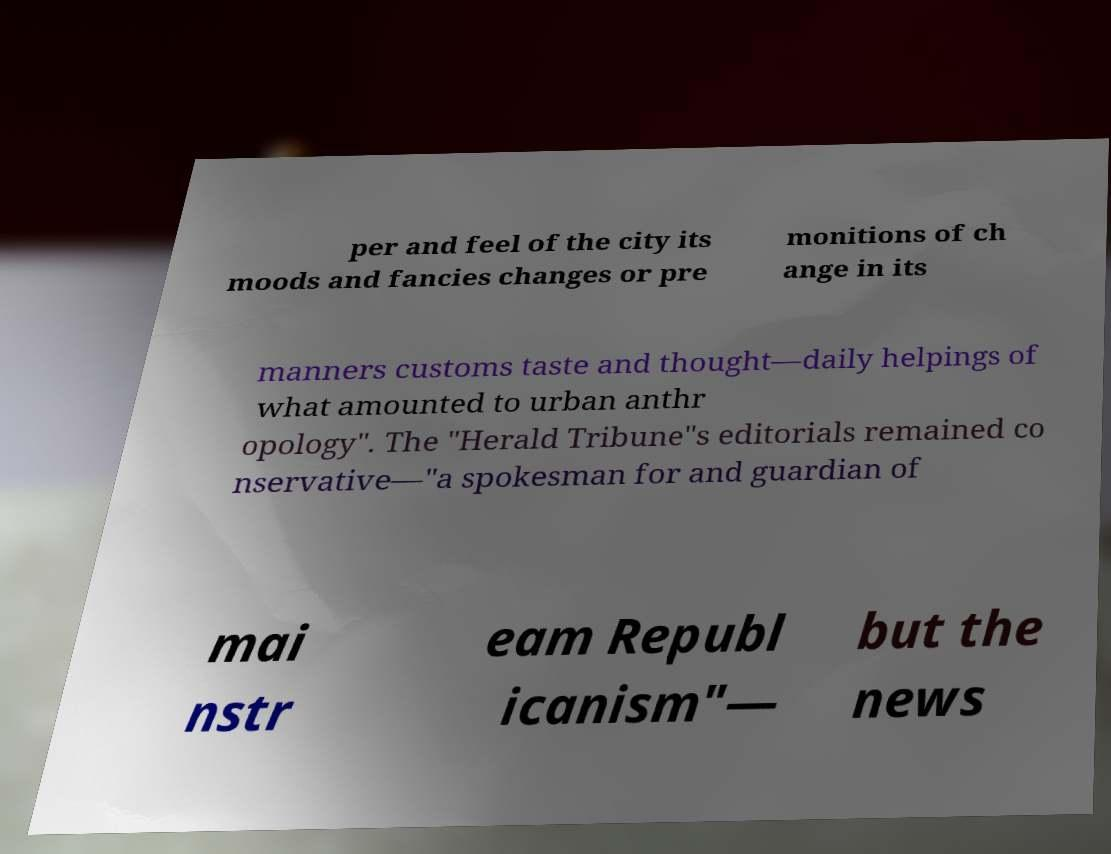Can you read and provide the text displayed in the image?This photo seems to have some interesting text. Can you extract and type it out for me? per and feel of the city its moods and fancies changes or pre monitions of ch ange in its manners customs taste and thought—daily helpings of what amounted to urban anthr opology". The "Herald Tribune"s editorials remained co nservative—"a spokesman for and guardian of mai nstr eam Republ icanism"— but the news 